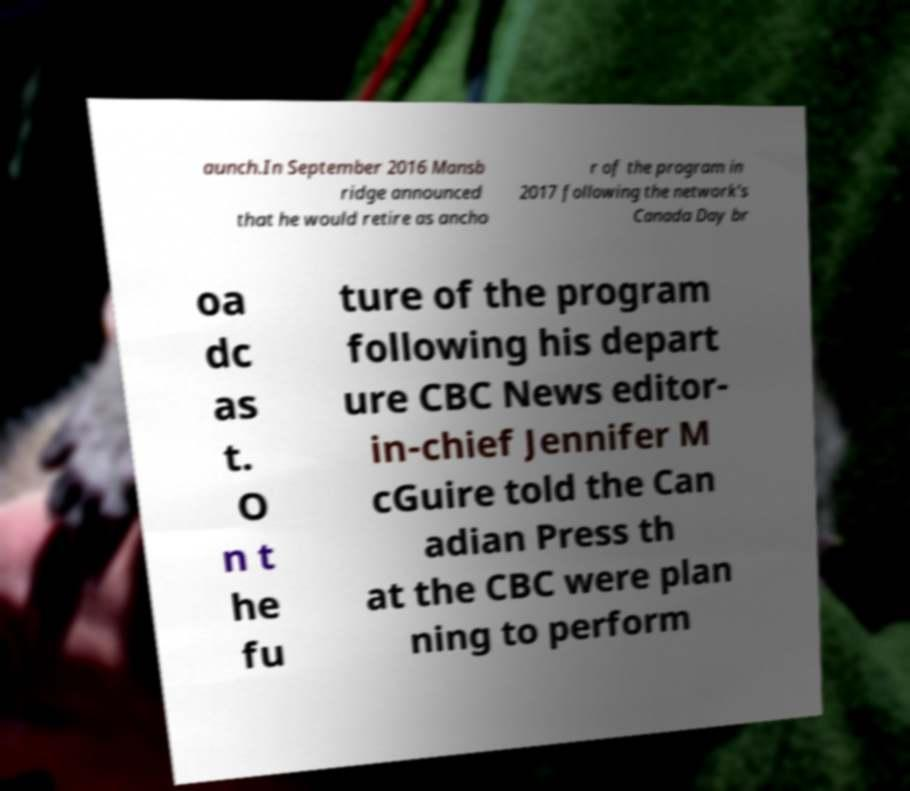What messages or text are displayed in this image? I need them in a readable, typed format. aunch.In September 2016 Mansb ridge announced that he would retire as ancho r of the program in 2017 following the network's Canada Day br oa dc as t. O n t he fu ture of the program following his depart ure CBC News editor- in-chief Jennifer M cGuire told the Can adian Press th at the CBC were plan ning to perform 